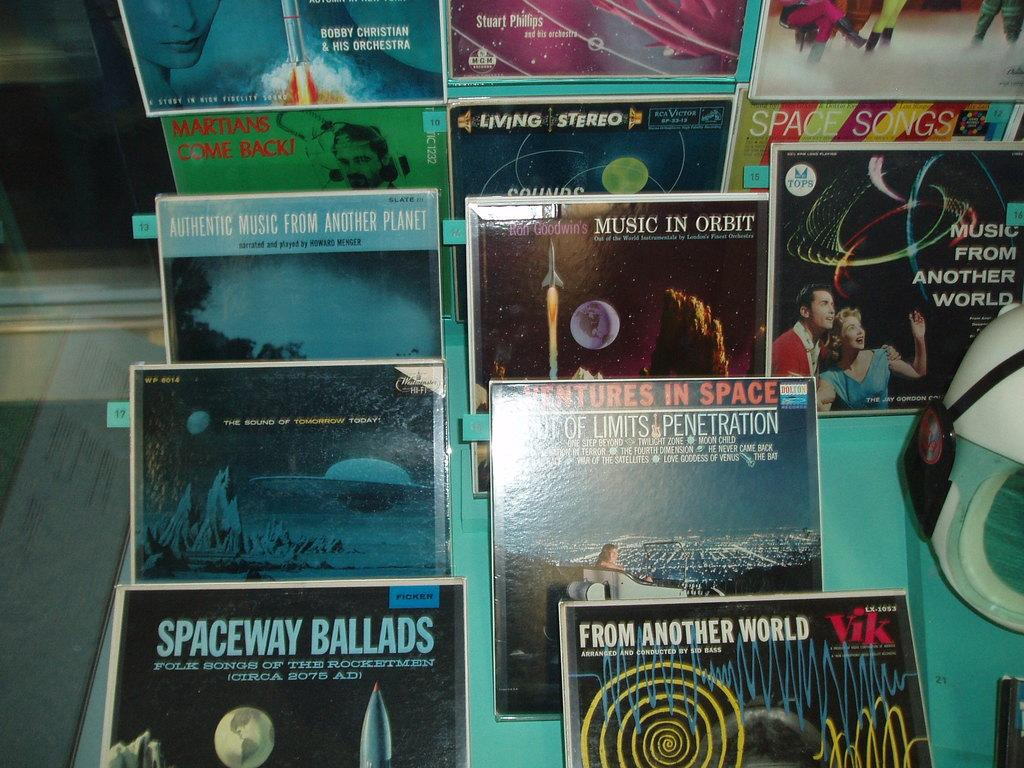<image>
Create a compact narrative representing the image presented. Many albums are on display like Spaceway Ballads. 